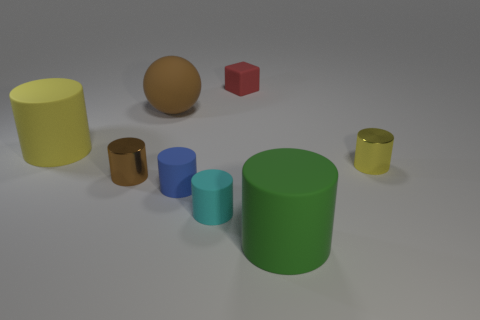Subtract all green balls. How many yellow cylinders are left? 2 Subtract all cyan rubber cylinders. How many cylinders are left? 5 Add 1 blue matte objects. How many objects exist? 9 Subtract all brown cylinders. How many cylinders are left? 5 Subtract 2 cylinders. How many cylinders are left? 4 Subtract all cylinders. How many objects are left? 2 Subtract all green cylinders. Subtract all cyan balls. How many cylinders are left? 5 Subtract all small red cubes. Subtract all small blue cylinders. How many objects are left? 6 Add 3 red objects. How many red objects are left? 4 Add 5 green objects. How many green objects exist? 6 